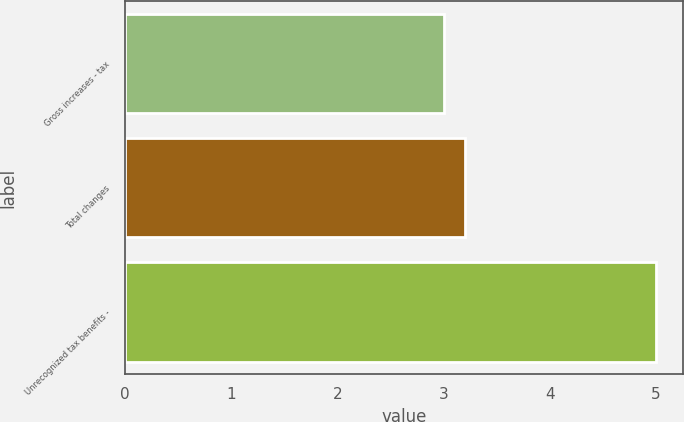Convert chart. <chart><loc_0><loc_0><loc_500><loc_500><bar_chart><fcel>Gross increases - tax<fcel>Total changes<fcel>Unrecognized tax benefits -<nl><fcel>3<fcel>3.2<fcel>5<nl></chart> 